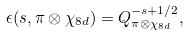Convert formula to latex. <formula><loc_0><loc_0><loc_500><loc_500>\epsilon ( s , \pi \otimes \chi _ { 8 d } ) = Q ^ { - s + 1 / 2 } _ { \pi \otimes \chi _ { 8 d } } ,</formula> 